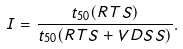Convert formula to latex. <formula><loc_0><loc_0><loc_500><loc_500>I = \frac { t _ { 5 0 } ( R T S ) } { t _ { 5 0 } ( R T S + V D S S ) } .</formula> 